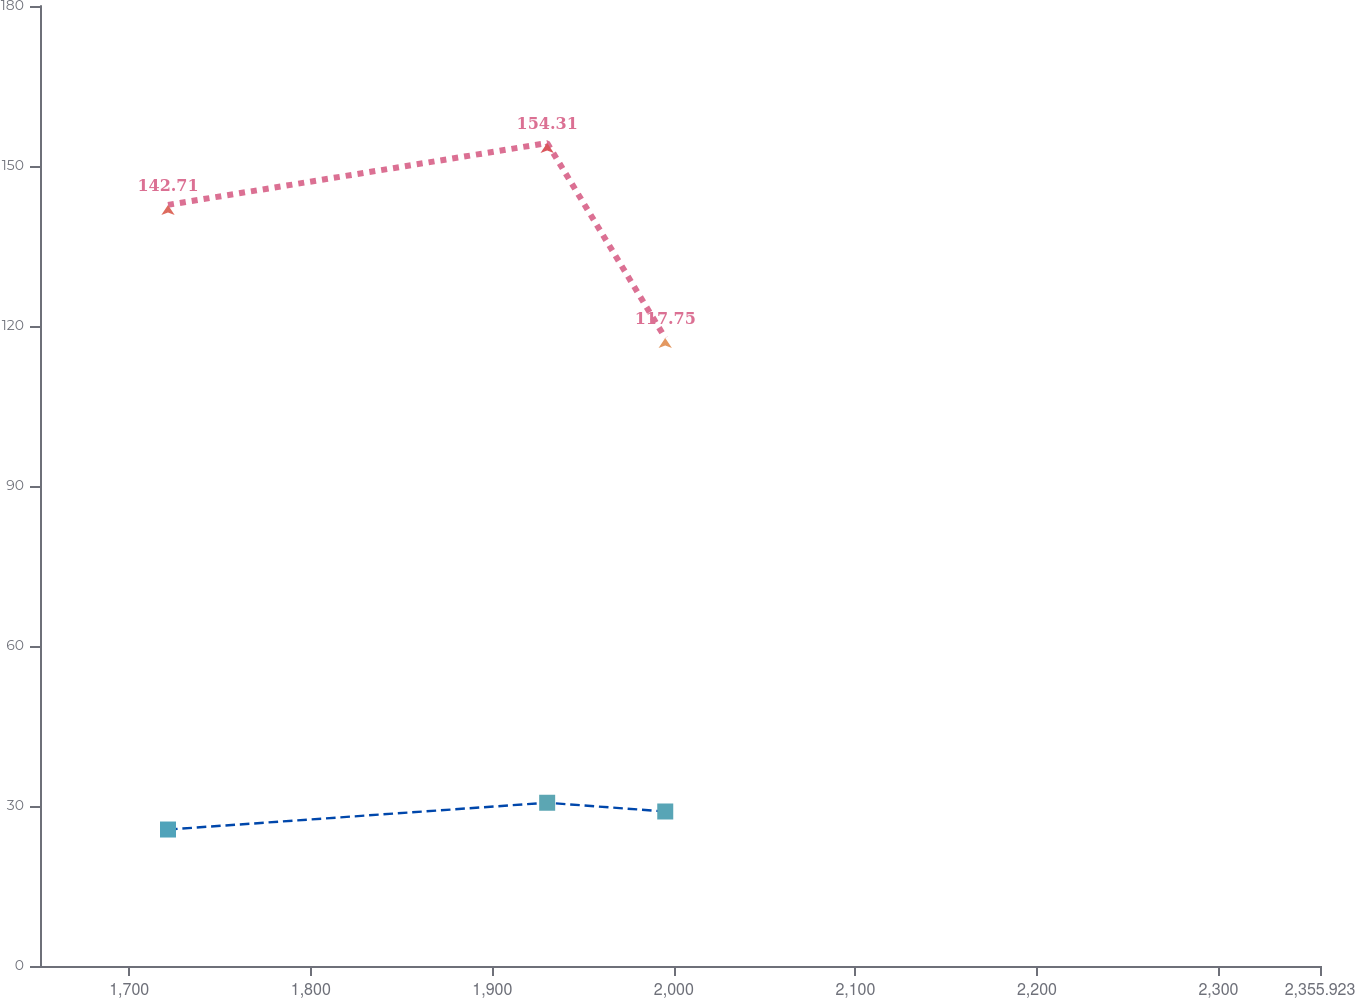Convert chart. <chart><loc_0><loc_0><loc_500><loc_500><line_chart><ecel><fcel>Pension Benefits<fcel>Other Postretirement Benefits<nl><fcel>1721.36<fcel>142.71<fcel>25.59<nl><fcel>1930.22<fcel>154.31<fcel>30.61<nl><fcel>1995.26<fcel>117.75<fcel>28.97<nl><fcel>2361.39<fcel>127.61<fcel>31.16<nl><fcel>2426.43<fcel>158.53<fcel>31.71<nl></chart> 